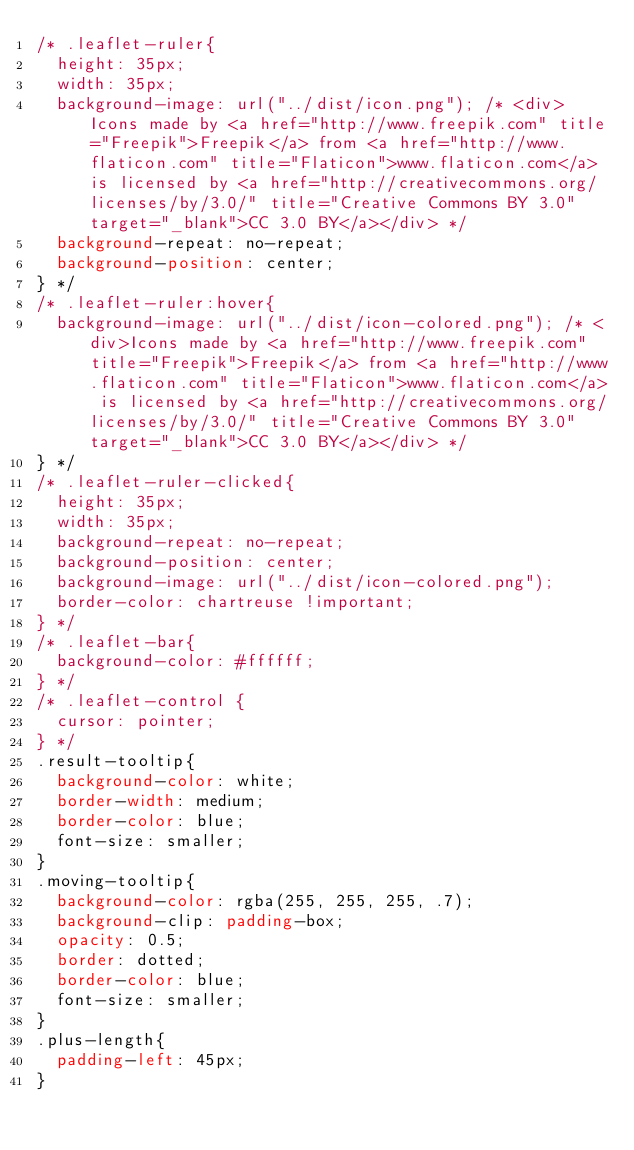<code> <loc_0><loc_0><loc_500><loc_500><_CSS_>/* .leaflet-ruler{
  height: 35px;
  width: 35px;
  background-image: url("../dist/icon.png"); /* <div>Icons made by <a href="http://www.freepik.com" title="Freepik">Freepik</a> from <a href="http://www.flaticon.com" title="Flaticon">www.flaticon.com</a> is licensed by <a href="http://creativecommons.org/licenses/by/3.0/" title="Creative Commons BY 3.0" target="_blank">CC 3.0 BY</a></div> */
  background-repeat: no-repeat;
  background-position: center;
} */
/* .leaflet-ruler:hover{
  background-image: url("../dist/icon-colored.png"); /* <div>Icons made by <a href="http://www.freepik.com" title="Freepik">Freepik</a> from <a href="http://www.flaticon.com" title="Flaticon">www.flaticon.com</a> is licensed by <a href="http://creativecommons.org/licenses/by/3.0/" title="Creative Commons BY 3.0" target="_blank">CC 3.0 BY</a></div> */
} */
/* .leaflet-ruler-clicked{
  height: 35px;
  width: 35px;
  background-repeat: no-repeat;
  background-position: center;
  background-image: url("../dist/icon-colored.png");
  border-color: chartreuse !important;
} */
/* .leaflet-bar{
  background-color: #ffffff;
} */
/* .leaflet-control {
  cursor: pointer;
} */
.result-tooltip{
  background-color: white;
  border-width: medium;
  border-color: blue;
  font-size: smaller;
}
.moving-tooltip{
  background-color: rgba(255, 255, 255, .7);
  background-clip: padding-box;
  opacity: 0.5;
  border: dotted;
  border-color: blue;
  font-size: smaller;
}
.plus-length{
  padding-left: 45px;
}
</code> 